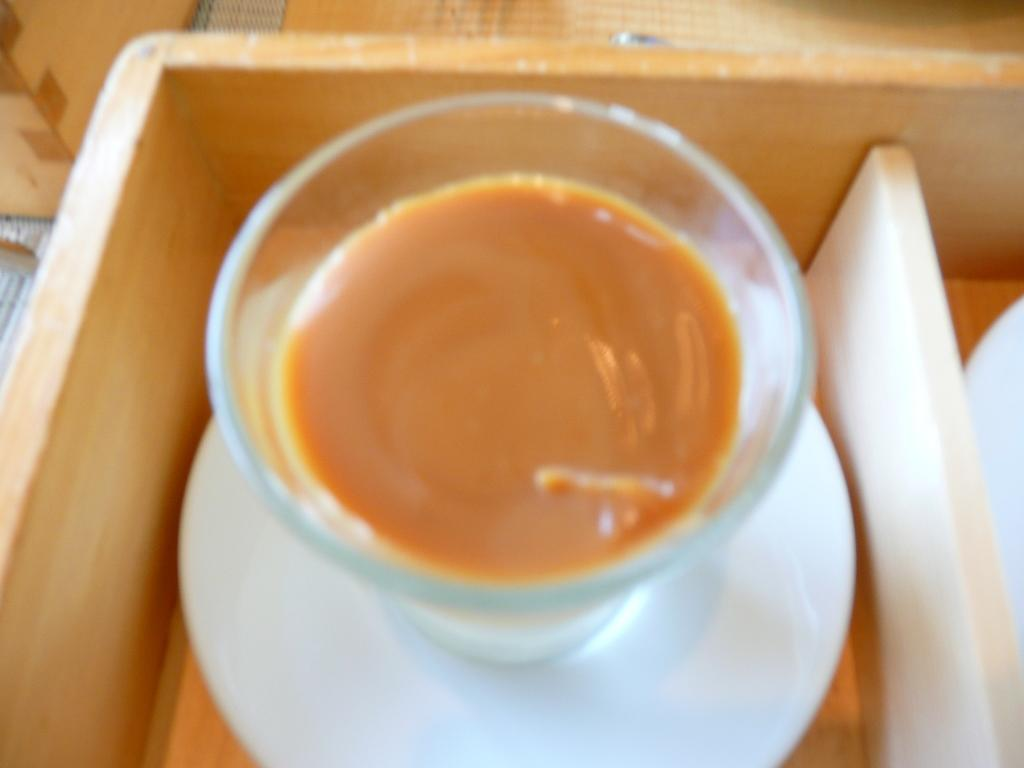What is in the glass that is visible in the image? There is a glass of juice in the image. What other item can be seen in the image besides the glass of juice? There is a saucer in the image. Reasoning: Let's think step by step by step in order to produce the conversation. We start by identifying the main subject in the image, which is the glass of juice. Then, we expand the conversation to include the other item that is also visible, which is the saucer. Each question is designed to elicit a specific detail about the image that is known from the provided facts. Absurd Question/Answer: Where is the cactus located in the image? There is no cactus present in the image. What type of cat can be seen playing with the saucer in the image? There is no cat present in the image. 